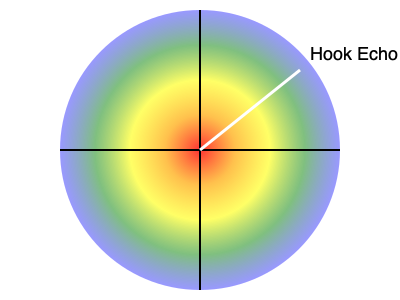In the weather radar image above, what does the white line pointing to the "Hook Echo" typically indicate for severe storm prediction in the Midwest? To understand the significance of the "Hook Echo" in severe storm prediction, let's break it down step-by-step:

1. Radar Interpretation: The image shows a colored radar representation of a storm system. The colors typically represent precipitation intensity, with red usually indicating the heaviest precipitation.

2. Hook Echo: The white line points to a feature called a "Hook Echo." This is a distinctive pattern on radar that looks like a hook extending from the main body of the storm.

3. Formation: A hook echo forms when the updraft of a supercell thunderstorm is so strong that it creates a rotation in the storm. This rotation pulls precipitation around it, creating the hook-shaped pattern.

4. Significance: The presence of a hook echo is a strong indicator of a rotating mesocyclone within the thunderstorm. This is crucial because:
   a) Mesocyclones are associated with the strongest and most severe thunderstorms.
   b) They have the potential to produce tornadoes.

5. Midwest Context: In the Midwest, where severe thunderstorms and tornadoes are common, especially during spring and early summer, a hook echo is a critical feature for forecasters to identify.

6. Warning System: When forecasters spot a hook echo, it often leads to the issuance of severe thunderstorm or tornado warnings for the affected areas.

7. Not Guaranteed: It's important to note that while a hook echo suggests a high probability of severe weather, not all hook echoes produce tornadoes, and not all tornadoes are preceded by visible hook echoes on radar.

In summary, the hook echo indicated in the image is a key feature that meteorologists use to identify potentially tornadic supercell thunderstorms, which are particularly relevant for severe weather prediction in the Midwest region.
Answer: Potential for tornado formation 